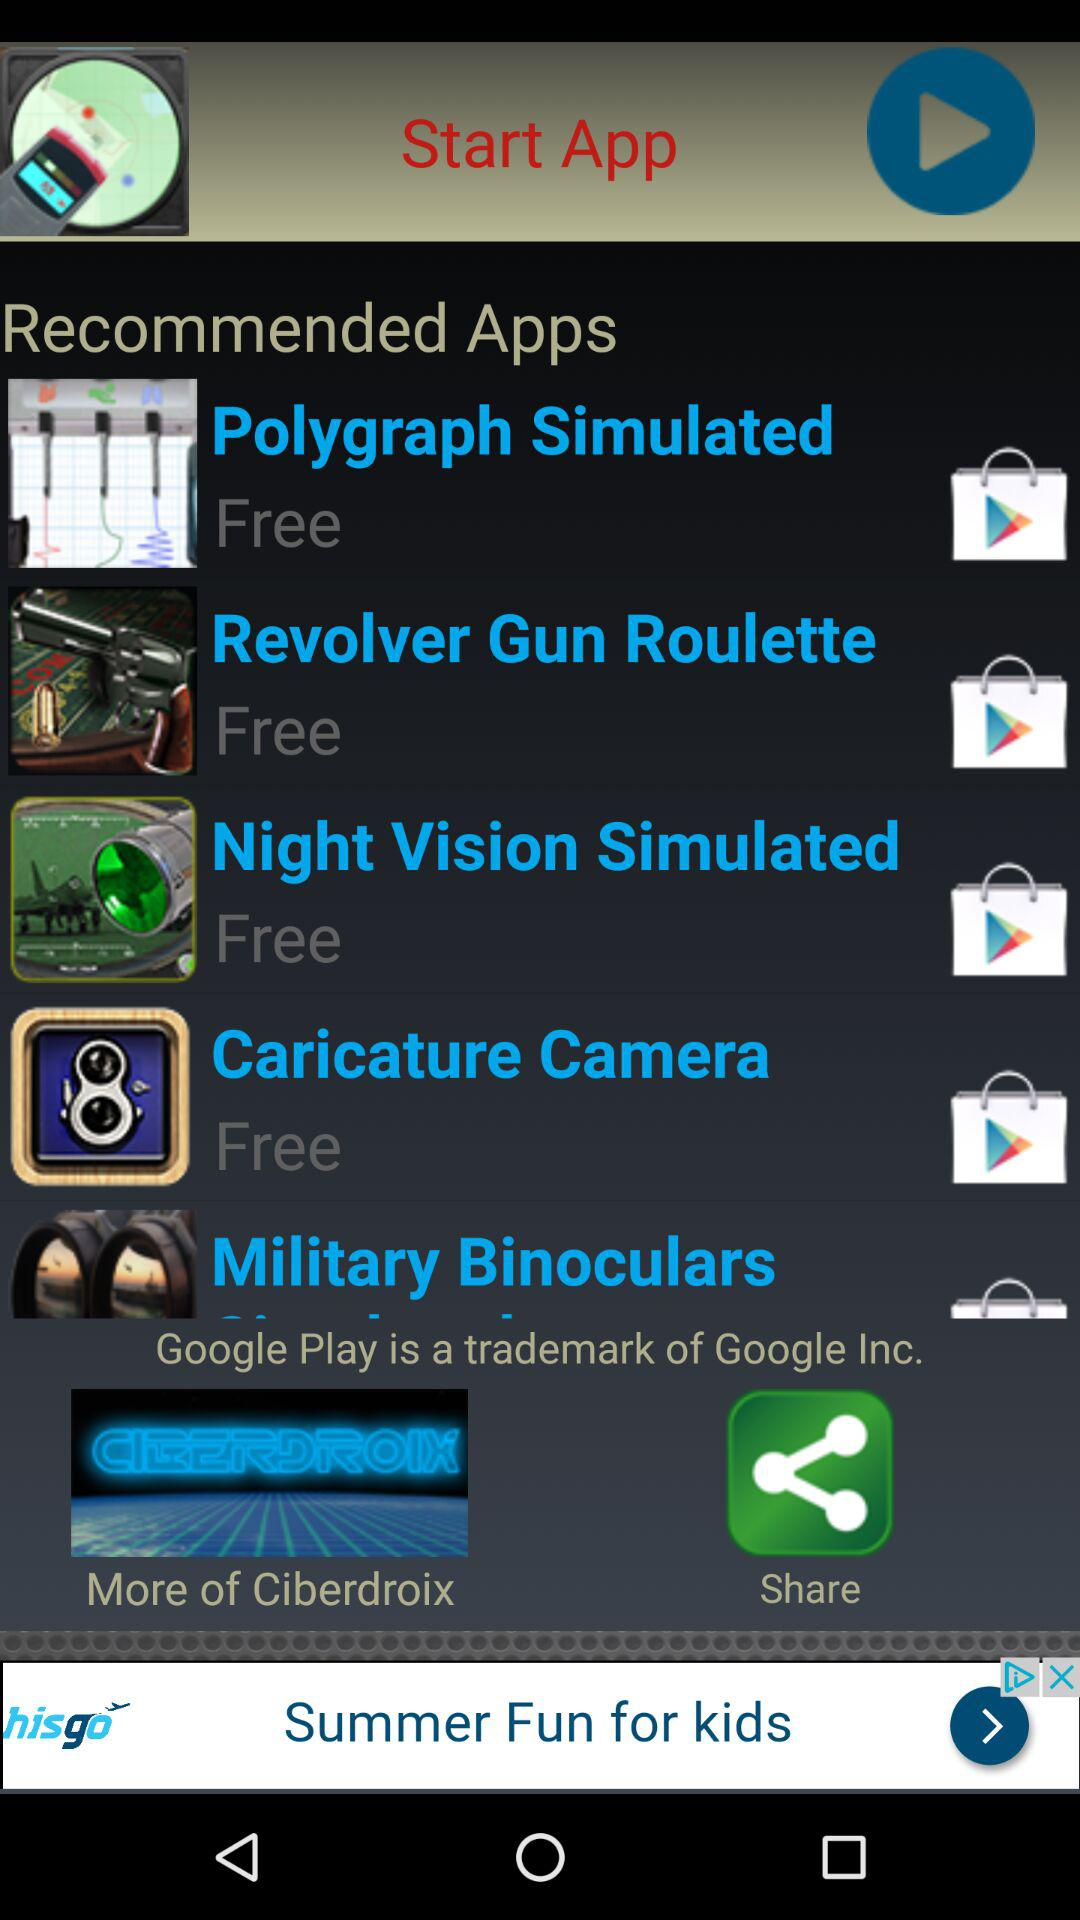How many apps have a price tag?
Answer the question using a single word or phrase. 0 